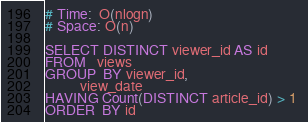<code> <loc_0><loc_0><loc_500><loc_500><_SQL_># Time:  O(nlogn)
# Space: O(n)

SELECT DISTINCT viewer_id AS id 
FROM   views 
GROUP  BY viewer_id, 
          view_date 
HAVING Count(DISTINCT article_id) > 1 
ORDER  BY id
</code> 